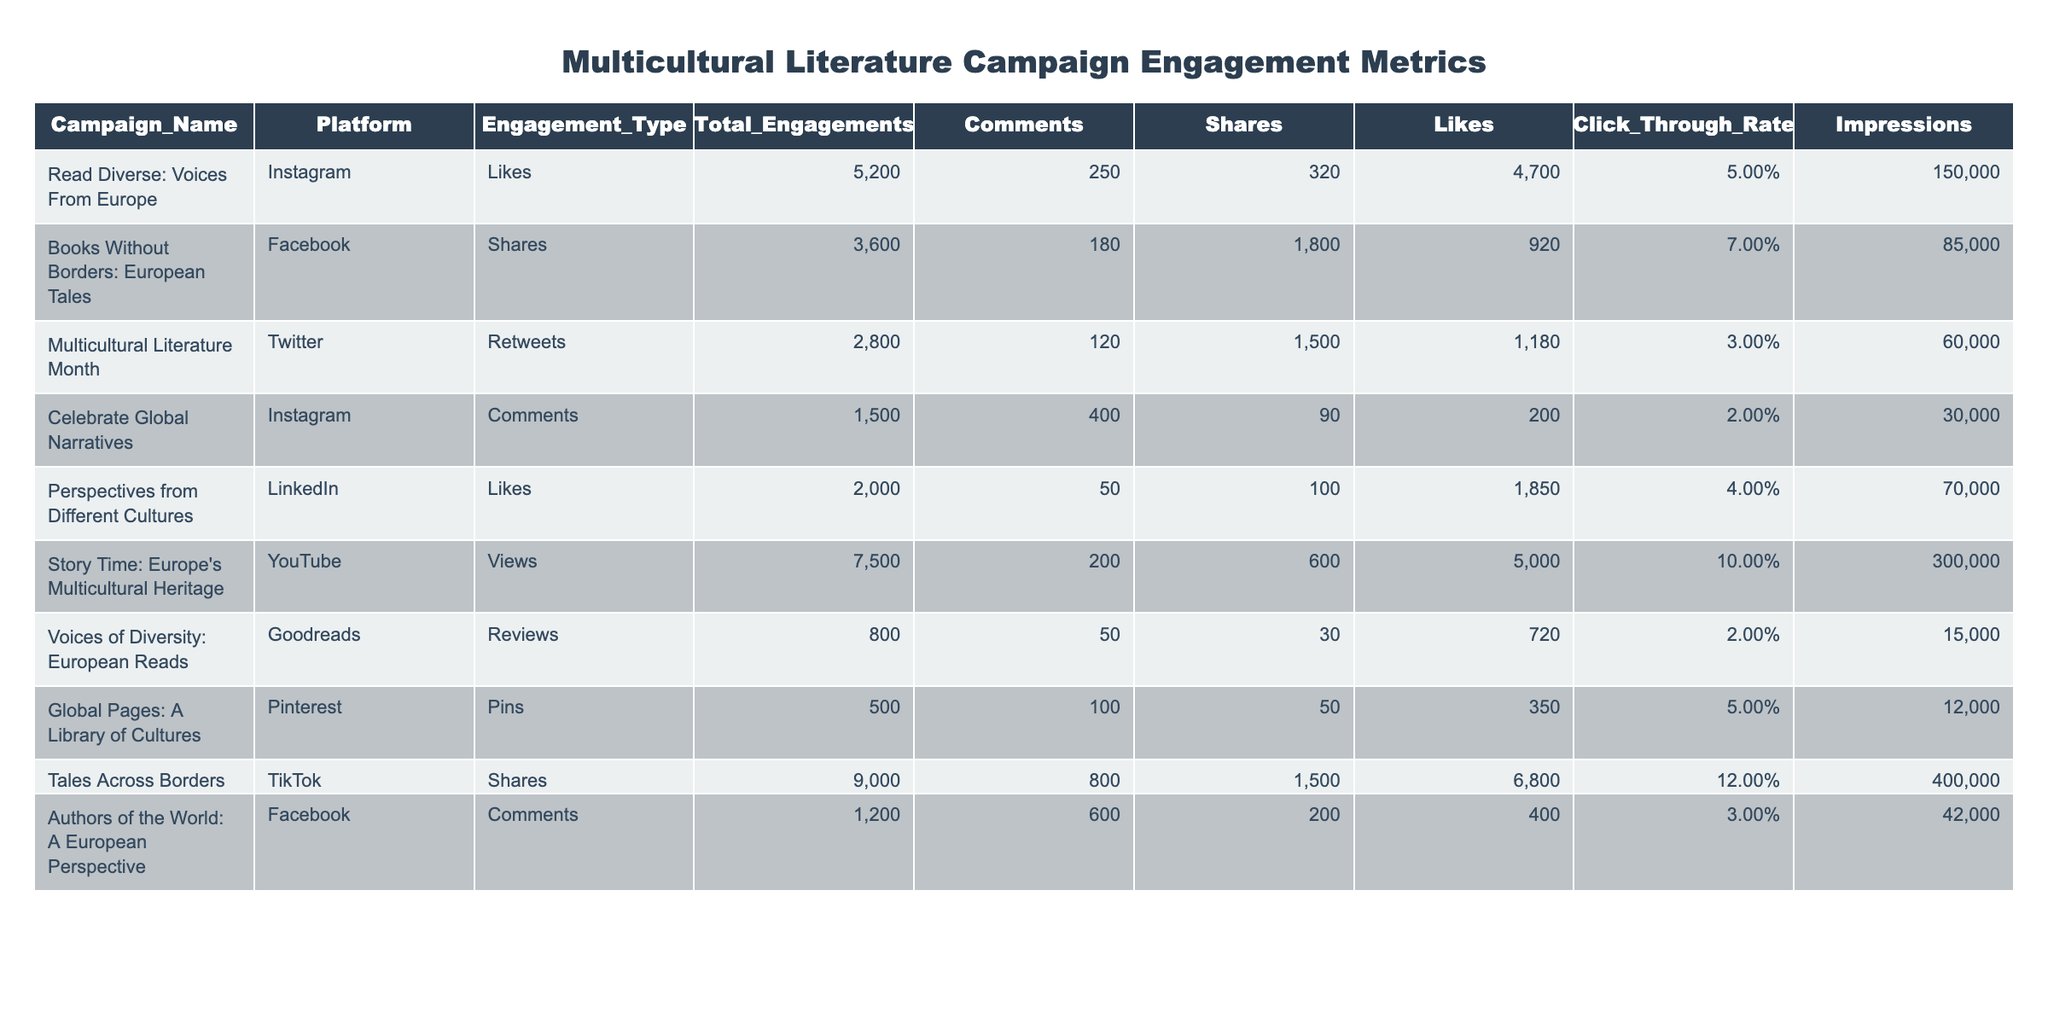What is the total number of likes for the "Read Diverse: Voices From Europe" campaign on Instagram? The table indicates that the total engagements for this campaign are 5200, which includes 4700 likes specifically. Therefore, the answer is simply the value under Likes for this campaign.
Answer: 4700 Which engagement type had the highest total engagements across all campaigns? By examining the Total Engagements column, we find the highest number of total engagements is 9000 for the "Tales Across Borders" campaign on TikTok. We identify the engagement type associated with this campaign, which is Shares.
Answer: Shares What is the click-through rate for the "Books Without Borders: European Tales" campaign on Facebook? The table lists the Click Through Rate for the "Books Without Borders" campaign as 0.07. This value can be directly retrieved from the corresponding row.
Answer: 0.07 How many total shares were recorded for the campaign "Tales Across Borders"? The entry for "Tales Across Borders" in the Shares engagement type shows a total of 1500 shares. This information is explicitly stated in the table.
Answer: 1500 Did the "Story Time: Europe's Multicultural Heritage" campaign have more likes or clicks? The total likes for this campaign are 5000, compared to the Click Through Rate which does not translate to a specific number of clicks in the table. Since likes are a well-defined numerical value (5000) and there’s no direct number for clicks provided, it implies there were more likes than clicks as there's insufficient data to state otherwise.
Answer: More likes What is the average number of comments across all campaigns? By summing all the Comments from each campaign, we get 250 + 180 + 120 + 400 + 50 + 200 + 50 + 100 + 800 + 600 = 2850. There are 10 campaigns total, so we divide 2850 by 10, resulting in an average of 285.
Answer: 285 How does the engagement type "Likes" compare to "Comments" in terms of total numbers across all campaigns? First, we sum the total Likes: 5200 + 2000 + 4700 + 1850 + 720 + 350 + 800 + 400 = 42000 Likes. Next, we sum the total Comments: 250 + 180 + 120 + 400 + 50 + 600 = 1600 Comments. Comparing these, Likes are significantly higher than Comments.
Answer: Likes are higher Is there any campaign with a Click Through Rate greater than 0.1? Reviewing the Click Through Rates listed, the highest value is 0.12 for the "Tales Across Borders" campaign, confirming that there is indeed a campaign exceeding 0.1.
Answer: Yes What is the total number of engagements for the campaign with the lowest number of total engagements? From the Total Engagements column, "Global Pages: A Library of Cultures" has the lowest total at 500. This value is directly present in the table.
Answer: 500 Which platform had the highest number of overall engagements? Examining the Total Engagements column, we compare engagement totals: Instagram (5200 + 1500), Facebook (3600 + 1200), Twitter (2800), LinkedIn (2000), YouTube (7500), Goodreads (800), Pinterest (500), and TikTok (9000). TikTok has the highest engagements at 9000.
Answer: TikTok 